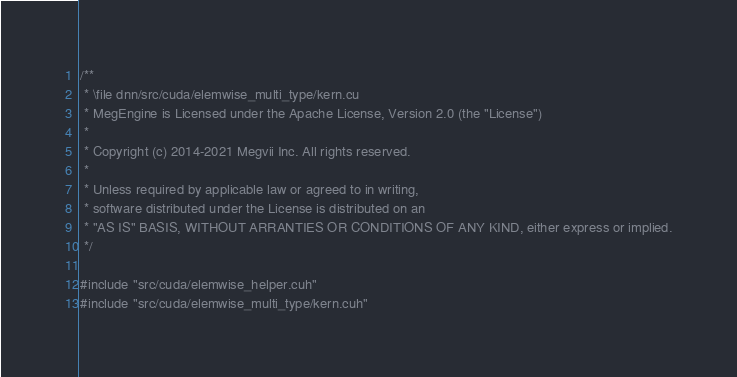Convert code to text. <code><loc_0><loc_0><loc_500><loc_500><_Cuda_>/**
 * \file dnn/src/cuda/elemwise_multi_type/kern.cu
 * MegEngine is Licensed under the Apache License, Version 2.0 (the "License")
 *
 * Copyright (c) 2014-2021 Megvii Inc. All rights reserved.
 *
 * Unless required by applicable law or agreed to in writing,
 * software distributed under the License is distributed on an
 * "AS IS" BASIS, WITHOUT ARRANTIES OR CONDITIONS OF ANY KIND, either express or implied.
 */

#include "src/cuda/elemwise_helper.cuh"
#include "src/cuda/elemwise_multi_type/kern.cuh"</code> 